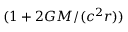<formula> <loc_0><loc_0><loc_500><loc_500>( 1 + 2 G M / ( c ^ { 2 } r ) )</formula> 